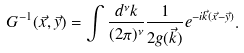<formula> <loc_0><loc_0><loc_500><loc_500>G ^ { - 1 } ( \vec { x } , \vec { y } ) = \int \frac { d ^ { \nu } k } { ( 2 \pi ) ^ { \nu } } \frac { 1 } { 2 g ( \vec { k } ) } e ^ { - i \vec { k } ( \vec { x } - \vec { y } ) } .</formula> 